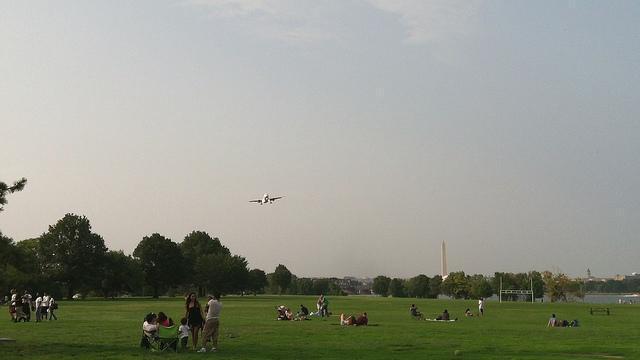How many airplanes are visible?
Give a very brief answer. 1. 